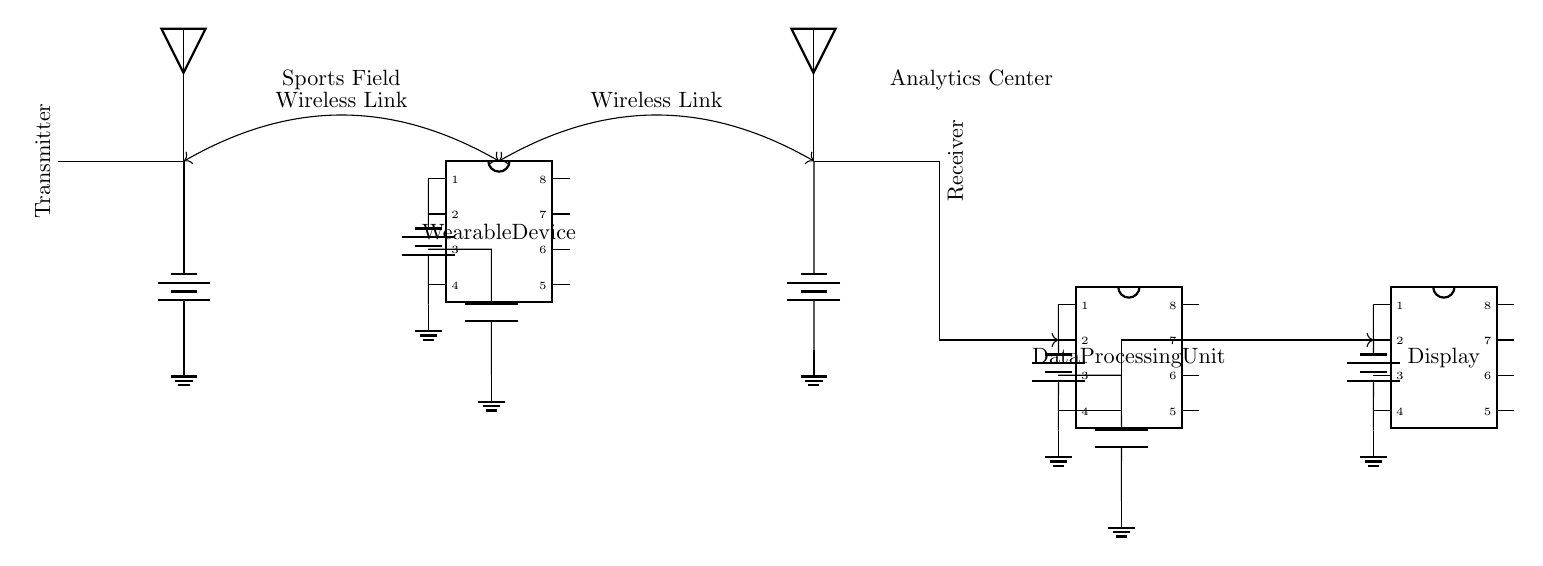What is the role of the transmitter? The transmitter is responsible for sending data wirelessly from the wearable device to the receiver. It is represented by the component labeled "Transmitter" in the circuit diagram.
Answer: Sending data What connects the wearable device to the receiver? A wireless link is the connection between the wearable device and the receiver, indicated by the double-headed arrow in the diagram.
Answer: Wireless link How many batteries are used in the circuit? There are four batteries shown in the circuit diagram, each one providing power to a different component: the transmitter, the wearable device, the receiver, and the data processing unit.
Answer: Four What is the main function of the data processing unit? The main function of the data processing unit is to process and analyze the data received from the wearable device. It is labeled as "Data Processing Unit" in the diagram.
Answer: Process data Which component displays the processed data? The component labeled "Display" is responsible for displaying the processed data from the data processing unit. It is shown in the circuit diagram.
Answer: Display What is connected to the receiver? The data processing unit is connected to the receiver through a directed link, as indicated by the arrow pointing from the receiver to the data processing unit in the circuit.
Answer: Data processing unit How does the wearable device receive power? The wearable device receives power from the battery connected directly to its pin, as indicated in the diagram by the line connecting them.
Answer: Battery 